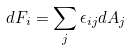Convert formula to latex. <formula><loc_0><loc_0><loc_500><loc_500>d F _ { i } = \sum _ { j } \epsilon _ { i j } d A _ { j }</formula> 